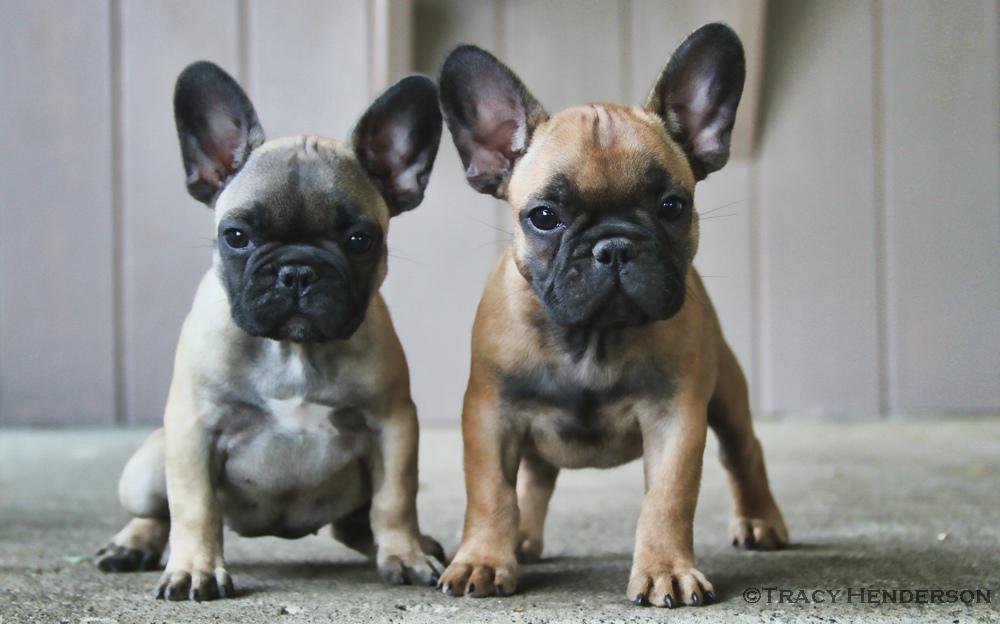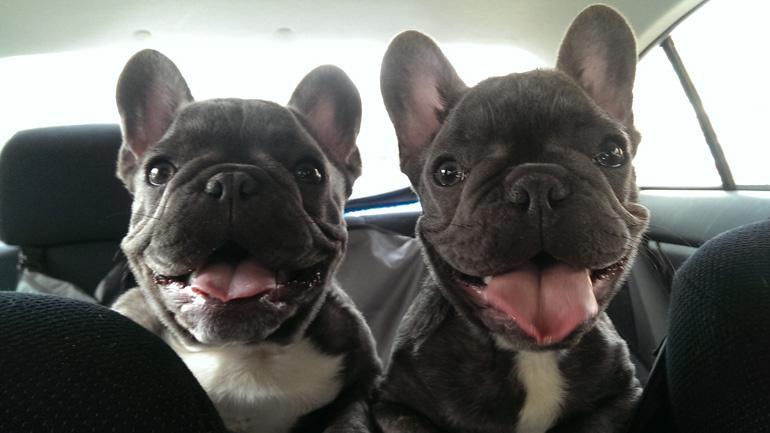The first image is the image on the left, the second image is the image on the right. Considering the images on both sides, is "An image shows two tan-colored dogs lounging on a cushioned item." valid? Answer yes or no. No. The first image is the image on the left, the second image is the image on the right. For the images shown, is this caption "There are two french bull dogs laying on a bed." true? Answer yes or no. No. 